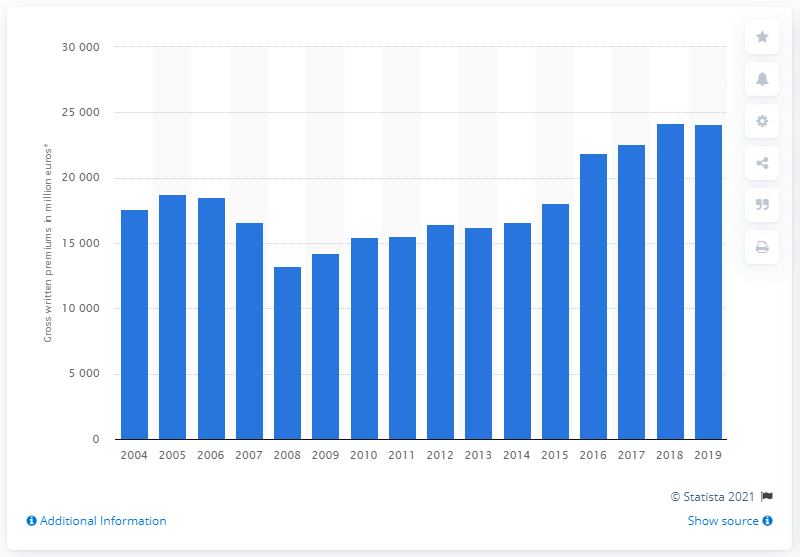Draw attention to some important aspects in this diagram. In 2008, the property insurance companies in the UK generated a total of £13,239 in gross written premiums. The highest value of gross written property insurance premiums in the UK in 2019 was 24,092. 